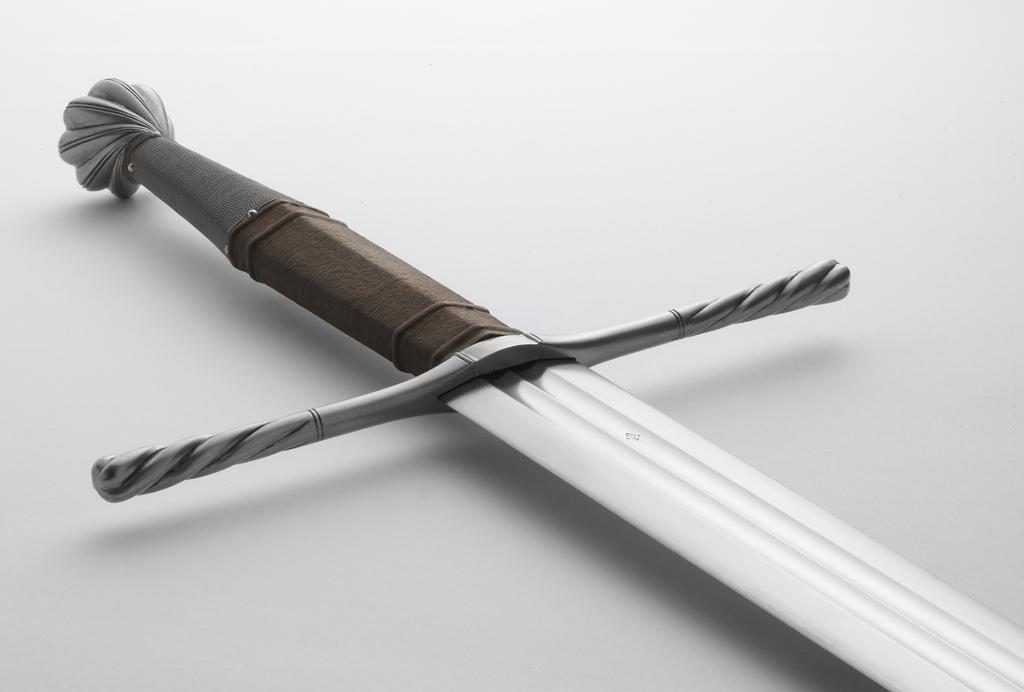Can you describe this image briefly? In the picture I can see a sword on a white color surface. 